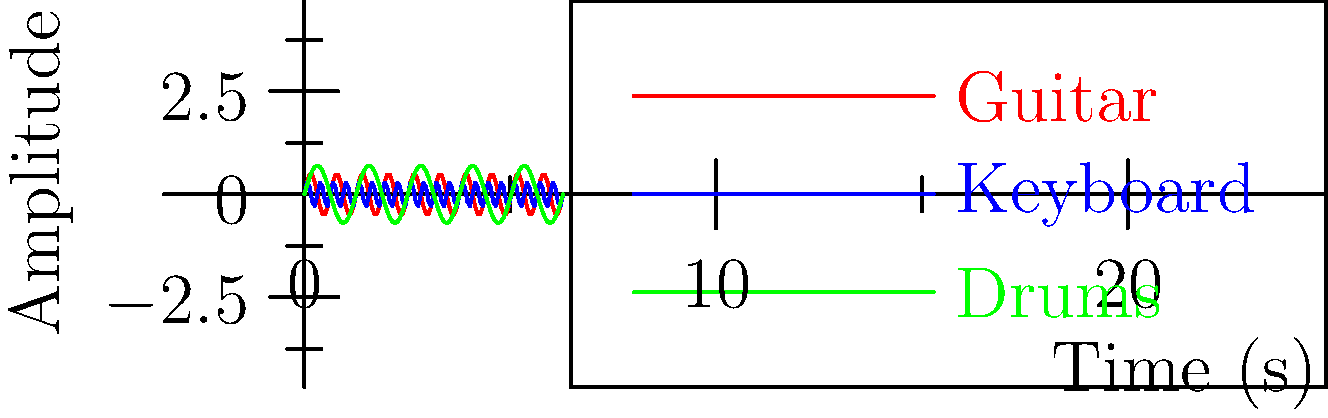In a live concert setting, three different instruments are playing simultaneously. The graph shows the sound wave patterns for a guitar (red), keyboard (blue), and drums (green) over a short time interval. Which instrument appears to have the highest frequency (fastest oscillation) based on the graph? To determine which instrument has the highest frequency, we need to analyze the oscillation patterns of each wave:

1. Frequency is related to how quickly a wave completes one cycle (oscillation).
2. A higher frequency means more cycles completed in the same amount of time.
3. On the graph, this translates to more peaks and troughs in a given interval.

Let's examine each instrument:

1. Guitar (red wave):
   - Shows a moderate number of oscillations.
   - Completes about 3-4 cycles in the given time frame.

2. Keyboard (blue wave):
   - Displays the most oscillations.
   - Completes approximately 6-7 cycles in the same time frame.

3. Drums (green wave):
   - Has the fewest oscillations.
   - Completes about 1-2 cycles in the given time frame.

Comparing these observations, we can see that the keyboard (blue wave) completes the most cycles in the given time interval, indicating it has the highest frequency among the three instruments.
Answer: Keyboard 